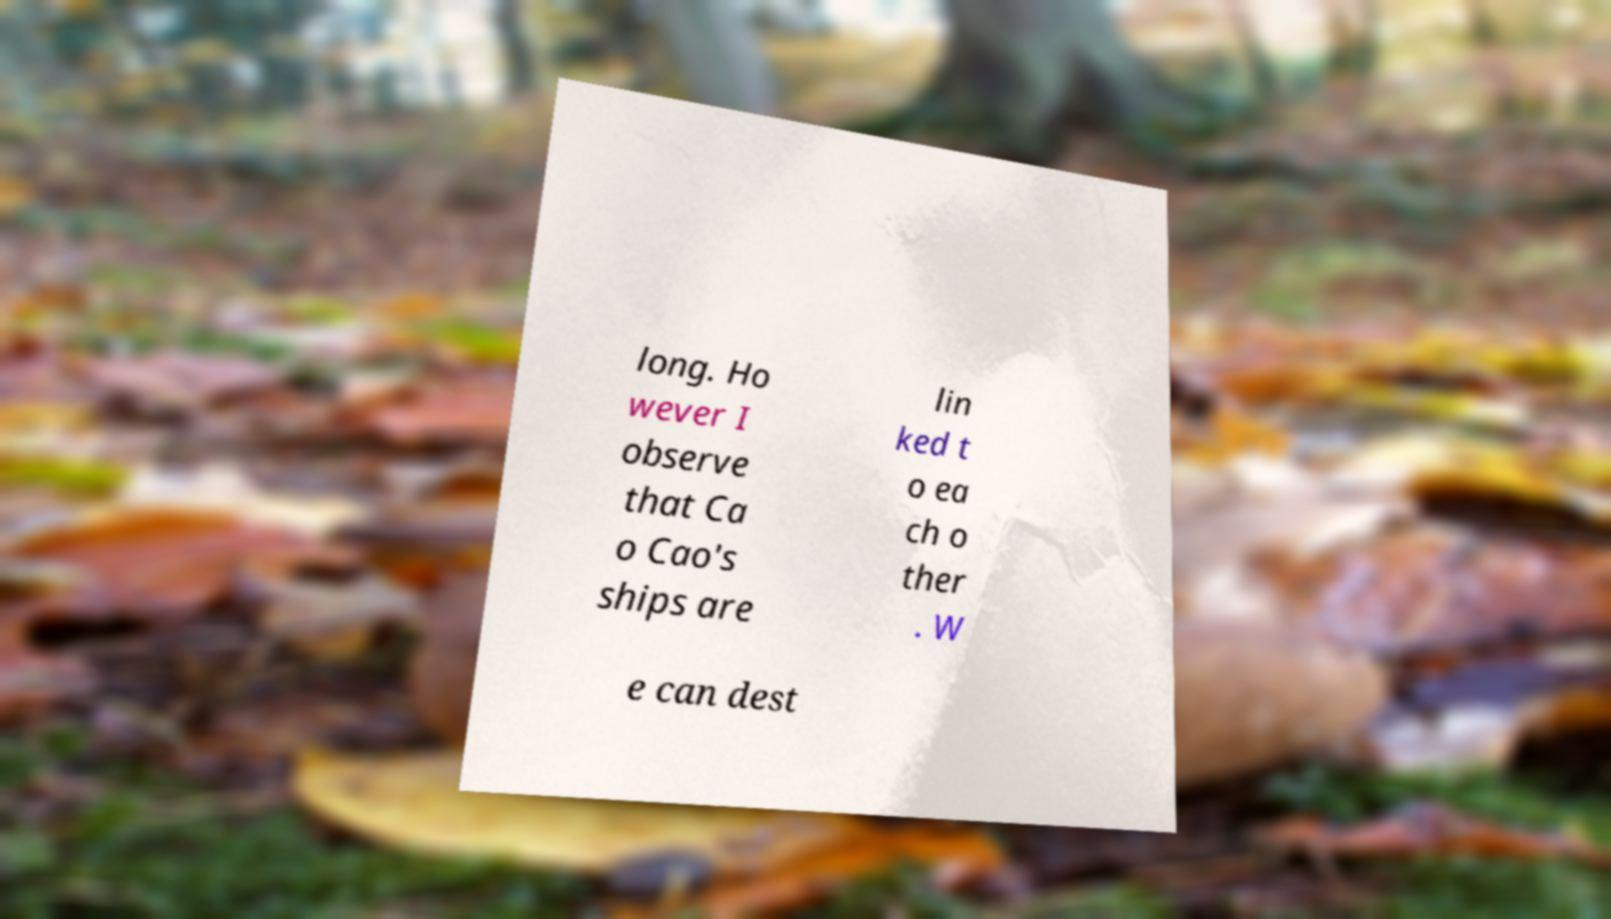Please identify and transcribe the text found in this image. long. Ho wever I observe that Ca o Cao's ships are lin ked t o ea ch o ther . W e can dest 